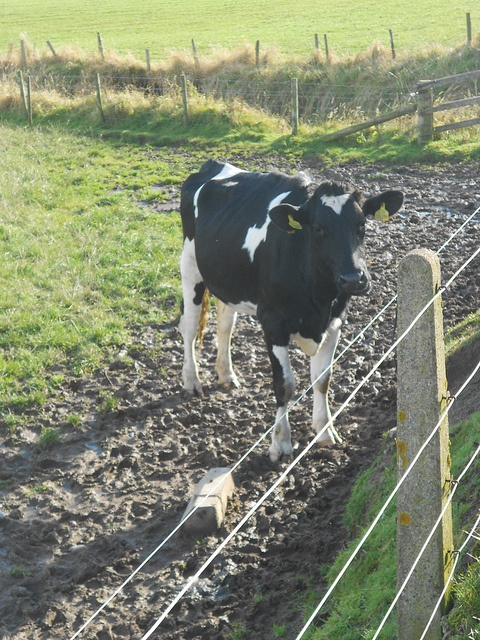Describe the objects in this image and their specific colors. I can see a cow in khaki, black, purple, gray, and darkgray tones in this image. 